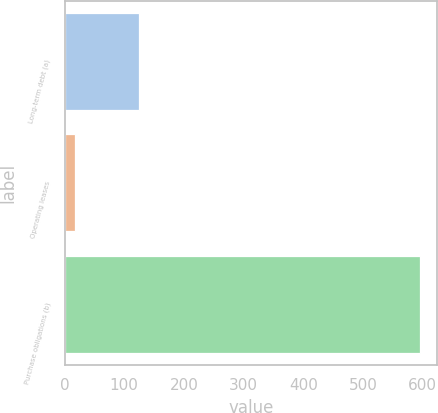Convert chart. <chart><loc_0><loc_0><loc_500><loc_500><bar_chart><fcel>Long-term debt (a)<fcel>Operating leases<fcel>Purchase obligations (b)<nl><fcel>125<fcel>17<fcel>595<nl></chart> 